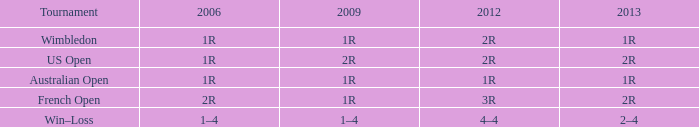What shows for 2006, when 2013 is 2–4? 1–4. 